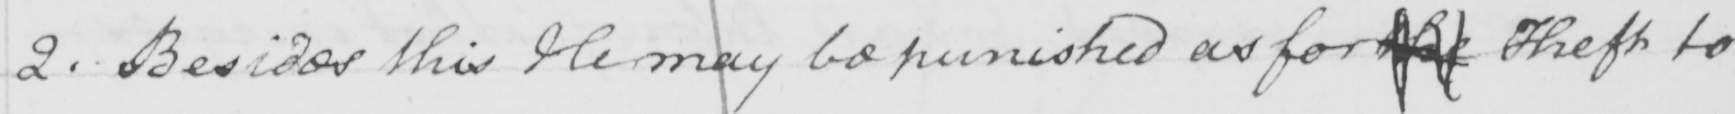Please provide the text content of this handwritten line. 2 . Besides this He may be punished as for the Theft to 